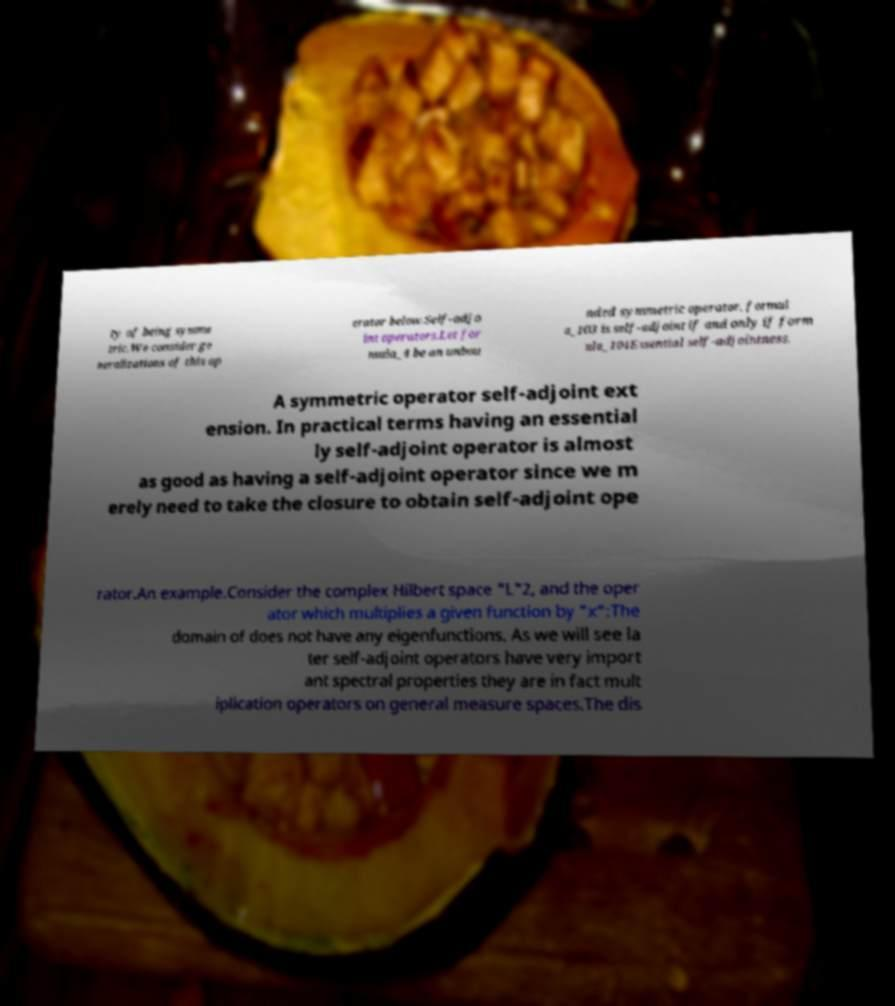What messages or text are displayed in this image? I need them in a readable, typed format. ty of being symme tric.We consider ge neralizations of this op erator below.Self-adjo int operators.Let for mula_4 be an unbou nded symmetric operator. formul a_103 is self-adjoint if and only if form ula_104Essential self-adjointness. A symmetric operator self-adjoint ext ension. In practical terms having an essential ly self-adjoint operator is almost as good as having a self-adjoint operator since we m erely need to take the closure to obtain self-adjoint ope rator.An example.Consider the complex Hilbert space "L"2, and the oper ator which multiplies a given function by "x":The domain of does not have any eigenfunctions. As we will see la ter self-adjoint operators have very import ant spectral properties they are in fact mult iplication operators on general measure spaces.The dis 